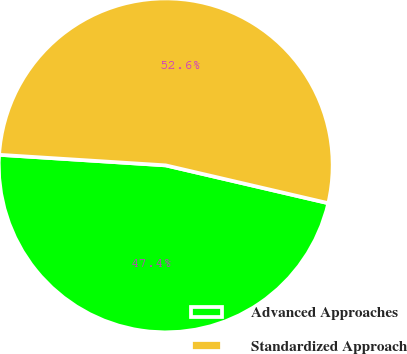Convert chart to OTSL. <chart><loc_0><loc_0><loc_500><loc_500><pie_chart><fcel>Advanced Approaches<fcel>Standardized Approach<nl><fcel>47.37%<fcel>52.63%<nl></chart> 